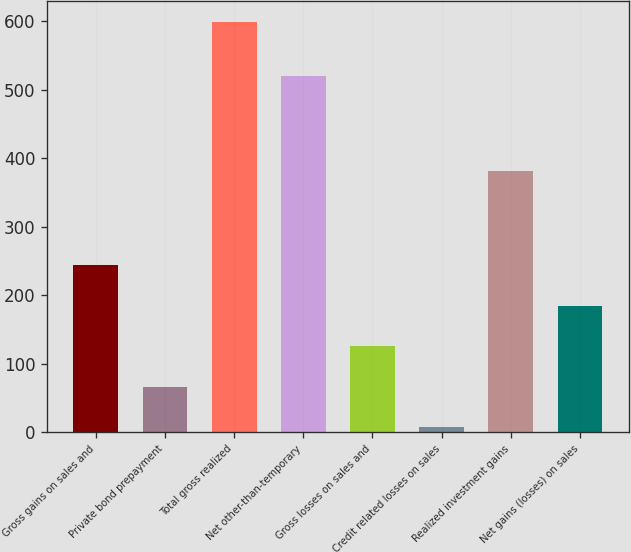Convert chart. <chart><loc_0><loc_0><loc_500><loc_500><bar_chart><fcel>Gross gains on sales and<fcel>Private bond prepayment<fcel>Total gross realized<fcel>Net other-than-temporary<fcel>Gross losses on sales and<fcel>Credit related losses on sales<fcel>Realized investment gains<fcel>Net gains (losses) on sales<nl><fcel>243.8<fcel>66.2<fcel>599<fcel>520<fcel>125.4<fcel>7<fcel>381<fcel>184.6<nl></chart> 